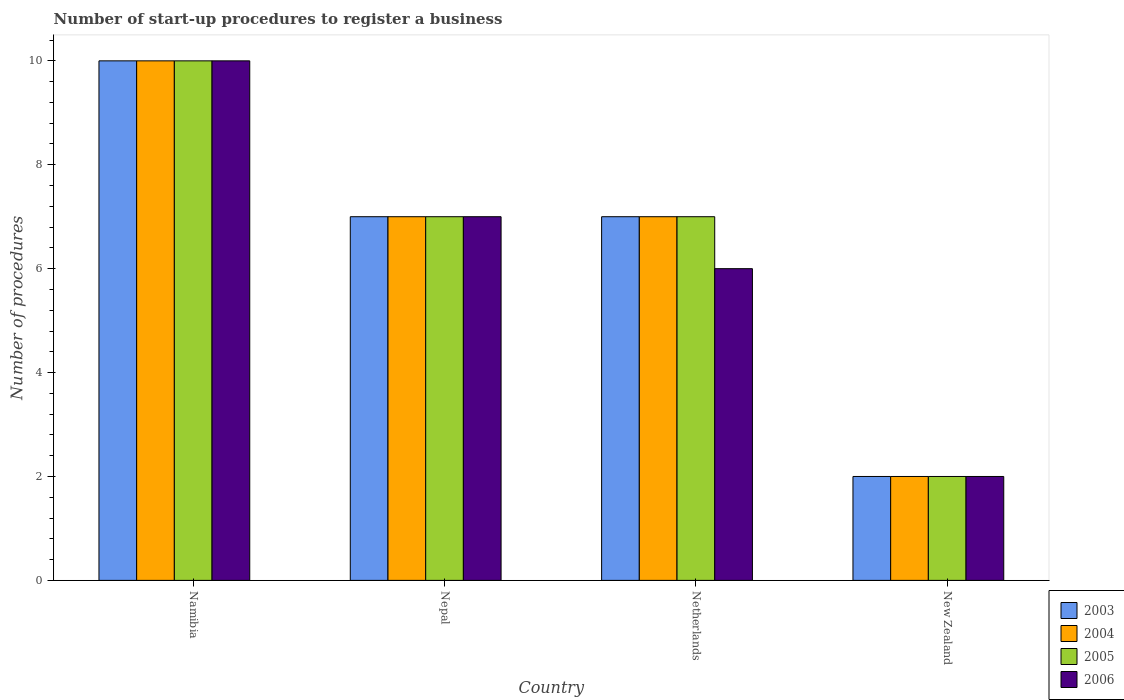How many different coloured bars are there?
Your answer should be very brief. 4. How many bars are there on the 1st tick from the right?
Give a very brief answer. 4. What is the label of the 1st group of bars from the left?
Your answer should be very brief. Namibia. In how many cases, is the number of bars for a given country not equal to the number of legend labels?
Keep it short and to the point. 0. What is the number of procedures required to register a business in 2003 in Nepal?
Offer a terse response. 7. Across all countries, what is the maximum number of procedures required to register a business in 2004?
Offer a very short reply. 10. In which country was the number of procedures required to register a business in 2006 maximum?
Your response must be concise. Namibia. In which country was the number of procedures required to register a business in 2006 minimum?
Offer a terse response. New Zealand. What is the difference between the number of procedures required to register a business in 2005 in Netherlands and that in New Zealand?
Make the answer very short. 5. What is the difference between the number of procedures required to register a business in 2003 in Nepal and the number of procedures required to register a business in 2005 in New Zealand?
Your answer should be very brief. 5. What is the average number of procedures required to register a business in 2005 per country?
Provide a short and direct response. 6.5. What is the difference between the number of procedures required to register a business of/in 2006 and number of procedures required to register a business of/in 2004 in Namibia?
Offer a very short reply. 0. What is the ratio of the number of procedures required to register a business in 2004 in Netherlands to that in New Zealand?
Provide a short and direct response. 3.5. Is the difference between the number of procedures required to register a business in 2006 in Nepal and New Zealand greater than the difference between the number of procedures required to register a business in 2004 in Nepal and New Zealand?
Make the answer very short. No. What is the difference between the highest and the second highest number of procedures required to register a business in 2006?
Offer a terse response. 4. What is the difference between the highest and the lowest number of procedures required to register a business in 2006?
Give a very brief answer. 8. In how many countries, is the number of procedures required to register a business in 2005 greater than the average number of procedures required to register a business in 2005 taken over all countries?
Offer a very short reply. 3. Is the sum of the number of procedures required to register a business in 2006 in Nepal and New Zealand greater than the maximum number of procedures required to register a business in 2004 across all countries?
Offer a very short reply. No. Is it the case that in every country, the sum of the number of procedures required to register a business in 2006 and number of procedures required to register a business in 2004 is greater than the sum of number of procedures required to register a business in 2005 and number of procedures required to register a business in 2003?
Your answer should be compact. No. What does the 3rd bar from the left in New Zealand represents?
Offer a very short reply. 2005. How many bars are there?
Your answer should be very brief. 16. Are the values on the major ticks of Y-axis written in scientific E-notation?
Provide a short and direct response. No. Does the graph contain any zero values?
Your response must be concise. No. Does the graph contain grids?
Make the answer very short. No. What is the title of the graph?
Provide a succinct answer. Number of start-up procedures to register a business. What is the label or title of the Y-axis?
Give a very brief answer. Number of procedures. What is the Number of procedures of 2004 in Namibia?
Your answer should be very brief. 10. What is the Number of procedures in 2005 in Namibia?
Provide a succinct answer. 10. What is the Number of procedures of 2006 in Namibia?
Your answer should be very brief. 10. What is the Number of procedures of 2003 in Nepal?
Make the answer very short. 7. What is the Number of procedures in 2006 in Nepal?
Provide a succinct answer. 7. What is the Number of procedures of 2006 in Netherlands?
Your answer should be compact. 6. What is the Number of procedures in 2004 in New Zealand?
Give a very brief answer. 2. What is the Number of procedures in 2005 in New Zealand?
Your answer should be very brief. 2. Across all countries, what is the maximum Number of procedures in 2005?
Keep it short and to the point. 10. Across all countries, what is the maximum Number of procedures in 2006?
Give a very brief answer. 10. Across all countries, what is the minimum Number of procedures in 2003?
Provide a short and direct response. 2. Across all countries, what is the minimum Number of procedures in 2004?
Provide a succinct answer. 2. Across all countries, what is the minimum Number of procedures in 2005?
Your answer should be very brief. 2. What is the total Number of procedures in 2003 in the graph?
Give a very brief answer. 26. What is the total Number of procedures in 2004 in the graph?
Give a very brief answer. 26. What is the total Number of procedures in 2006 in the graph?
Your answer should be compact. 25. What is the difference between the Number of procedures in 2004 in Namibia and that in Nepal?
Your answer should be very brief. 3. What is the difference between the Number of procedures of 2005 in Namibia and that in Nepal?
Ensure brevity in your answer.  3. What is the difference between the Number of procedures of 2003 in Namibia and that in Netherlands?
Ensure brevity in your answer.  3. What is the difference between the Number of procedures in 2006 in Namibia and that in Netherlands?
Your answer should be compact. 4. What is the difference between the Number of procedures of 2004 in Namibia and that in New Zealand?
Make the answer very short. 8. What is the difference between the Number of procedures of 2005 in Namibia and that in New Zealand?
Make the answer very short. 8. What is the difference between the Number of procedures in 2005 in Nepal and that in Netherlands?
Your answer should be compact. 0. What is the difference between the Number of procedures of 2004 in Nepal and that in New Zealand?
Ensure brevity in your answer.  5. What is the difference between the Number of procedures of 2005 in Nepal and that in New Zealand?
Your response must be concise. 5. What is the difference between the Number of procedures in 2006 in Nepal and that in New Zealand?
Offer a terse response. 5. What is the difference between the Number of procedures of 2003 in Netherlands and that in New Zealand?
Provide a succinct answer. 5. What is the difference between the Number of procedures in 2004 in Netherlands and that in New Zealand?
Your answer should be very brief. 5. What is the difference between the Number of procedures of 2005 in Netherlands and that in New Zealand?
Offer a very short reply. 5. What is the difference between the Number of procedures of 2003 in Namibia and the Number of procedures of 2004 in Nepal?
Your answer should be compact. 3. What is the difference between the Number of procedures of 2003 in Namibia and the Number of procedures of 2006 in Nepal?
Provide a succinct answer. 3. What is the difference between the Number of procedures in 2004 in Namibia and the Number of procedures in 2005 in Nepal?
Your response must be concise. 3. What is the difference between the Number of procedures of 2005 in Namibia and the Number of procedures of 2006 in Nepal?
Make the answer very short. 3. What is the difference between the Number of procedures of 2003 in Namibia and the Number of procedures of 2004 in Netherlands?
Keep it short and to the point. 3. What is the difference between the Number of procedures in 2003 in Namibia and the Number of procedures in 2005 in Netherlands?
Your answer should be very brief. 3. What is the difference between the Number of procedures in 2004 in Namibia and the Number of procedures in 2005 in Netherlands?
Your response must be concise. 3. What is the difference between the Number of procedures in 2003 in Namibia and the Number of procedures in 2004 in New Zealand?
Give a very brief answer. 8. What is the difference between the Number of procedures in 2003 in Namibia and the Number of procedures in 2006 in New Zealand?
Give a very brief answer. 8. What is the difference between the Number of procedures of 2004 in Namibia and the Number of procedures of 2005 in New Zealand?
Ensure brevity in your answer.  8. What is the difference between the Number of procedures of 2005 in Namibia and the Number of procedures of 2006 in New Zealand?
Your answer should be very brief. 8. What is the difference between the Number of procedures in 2003 in Nepal and the Number of procedures in 2006 in Netherlands?
Offer a very short reply. 1. What is the difference between the Number of procedures in 2004 in Nepal and the Number of procedures in 2005 in Netherlands?
Offer a terse response. 0. What is the difference between the Number of procedures of 2005 in Nepal and the Number of procedures of 2006 in Netherlands?
Make the answer very short. 1. What is the difference between the Number of procedures in 2004 in Nepal and the Number of procedures in 2005 in New Zealand?
Your response must be concise. 5. What is the difference between the Number of procedures in 2003 in Netherlands and the Number of procedures in 2004 in New Zealand?
Ensure brevity in your answer.  5. What is the difference between the Number of procedures of 2004 in Netherlands and the Number of procedures of 2006 in New Zealand?
Your response must be concise. 5. What is the difference between the Number of procedures in 2005 in Netherlands and the Number of procedures in 2006 in New Zealand?
Your answer should be compact. 5. What is the average Number of procedures in 2004 per country?
Make the answer very short. 6.5. What is the average Number of procedures in 2005 per country?
Your answer should be very brief. 6.5. What is the average Number of procedures of 2006 per country?
Provide a succinct answer. 6.25. What is the difference between the Number of procedures of 2003 and Number of procedures of 2004 in Namibia?
Your answer should be very brief. 0. What is the difference between the Number of procedures in 2004 and Number of procedures in 2005 in Namibia?
Provide a short and direct response. 0. What is the difference between the Number of procedures in 2003 and Number of procedures in 2004 in Nepal?
Make the answer very short. 0. What is the difference between the Number of procedures of 2004 and Number of procedures of 2005 in Nepal?
Keep it short and to the point. 0. What is the difference between the Number of procedures of 2005 and Number of procedures of 2006 in Nepal?
Provide a short and direct response. 0. What is the difference between the Number of procedures of 2004 and Number of procedures of 2005 in Netherlands?
Give a very brief answer. 0. What is the difference between the Number of procedures in 2004 and Number of procedures in 2006 in Netherlands?
Your answer should be compact. 1. What is the difference between the Number of procedures of 2004 and Number of procedures of 2006 in New Zealand?
Provide a short and direct response. 0. What is the ratio of the Number of procedures of 2003 in Namibia to that in Nepal?
Ensure brevity in your answer.  1.43. What is the ratio of the Number of procedures in 2004 in Namibia to that in Nepal?
Keep it short and to the point. 1.43. What is the ratio of the Number of procedures of 2005 in Namibia to that in Nepal?
Provide a short and direct response. 1.43. What is the ratio of the Number of procedures of 2006 in Namibia to that in Nepal?
Give a very brief answer. 1.43. What is the ratio of the Number of procedures of 2003 in Namibia to that in Netherlands?
Keep it short and to the point. 1.43. What is the ratio of the Number of procedures in 2004 in Namibia to that in Netherlands?
Offer a terse response. 1.43. What is the ratio of the Number of procedures of 2005 in Namibia to that in Netherlands?
Keep it short and to the point. 1.43. What is the ratio of the Number of procedures in 2004 in Namibia to that in New Zealand?
Offer a terse response. 5. What is the ratio of the Number of procedures of 2006 in Namibia to that in New Zealand?
Your response must be concise. 5. What is the ratio of the Number of procedures of 2003 in Nepal to that in New Zealand?
Offer a terse response. 3.5. What is the ratio of the Number of procedures in 2005 in Nepal to that in New Zealand?
Give a very brief answer. 3.5. What is the ratio of the Number of procedures of 2003 in Netherlands to that in New Zealand?
Make the answer very short. 3.5. What is the ratio of the Number of procedures of 2006 in Netherlands to that in New Zealand?
Give a very brief answer. 3. What is the difference between the highest and the second highest Number of procedures of 2003?
Offer a terse response. 3. What is the difference between the highest and the second highest Number of procedures of 2004?
Keep it short and to the point. 3. What is the difference between the highest and the second highest Number of procedures in 2006?
Give a very brief answer. 3. What is the difference between the highest and the lowest Number of procedures of 2003?
Provide a short and direct response. 8. What is the difference between the highest and the lowest Number of procedures in 2004?
Make the answer very short. 8. What is the difference between the highest and the lowest Number of procedures in 2005?
Provide a succinct answer. 8. What is the difference between the highest and the lowest Number of procedures of 2006?
Your answer should be very brief. 8. 